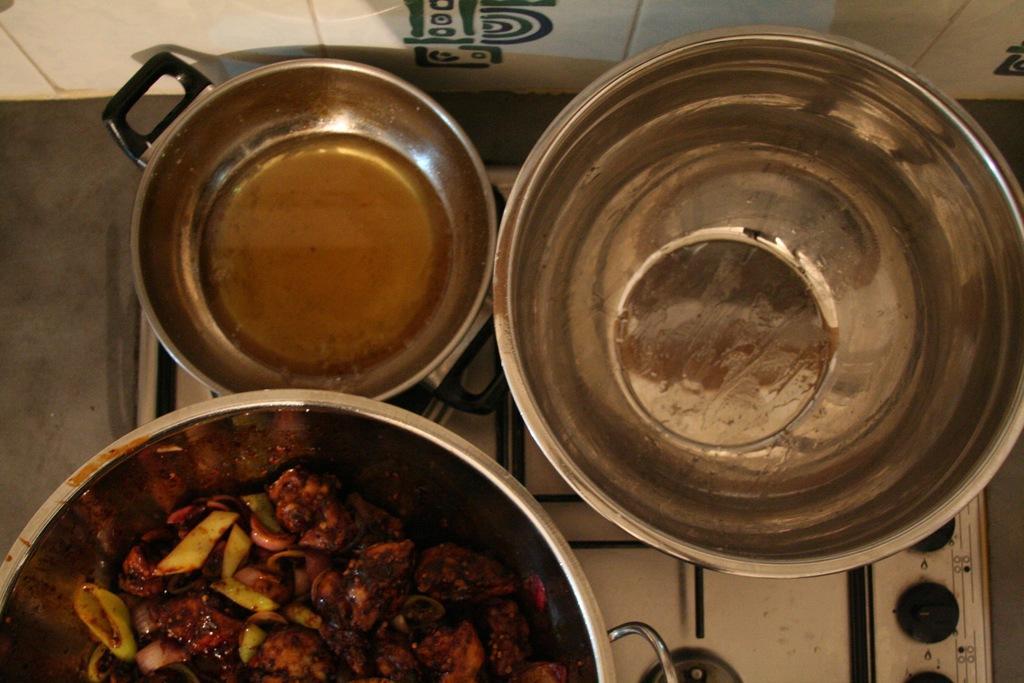How would you summarize this image in a sentence or two? In this image there are three bowls with some food and oil in it on the stove, behind the stove there is a wall. 